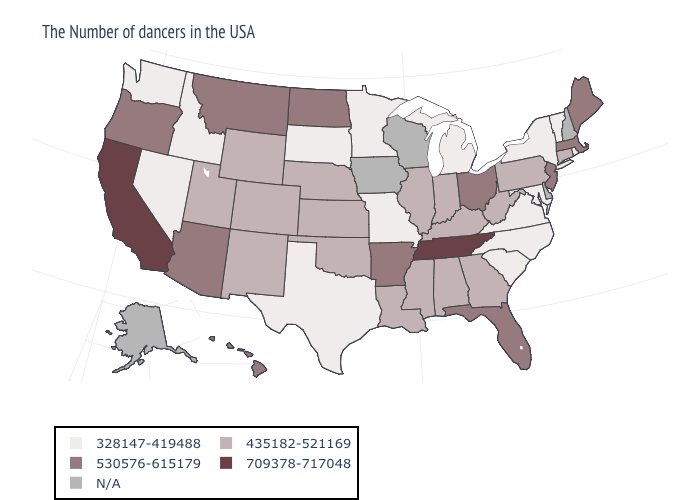Name the states that have a value in the range 328147-419488?
Answer briefly. Rhode Island, Vermont, New York, Maryland, Virginia, North Carolina, South Carolina, Michigan, Missouri, Minnesota, Texas, South Dakota, Idaho, Nevada, Washington. What is the value of Hawaii?
Answer briefly. 530576-615179. Does Michigan have the lowest value in the USA?
Concise answer only. Yes. What is the value of Maine?
Concise answer only. 530576-615179. What is the value of South Carolina?
Short answer required. 328147-419488. How many symbols are there in the legend?
Be succinct. 5. Name the states that have a value in the range 435182-521169?
Short answer required. Connecticut, Pennsylvania, West Virginia, Georgia, Kentucky, Indiana, Alabama, Illinois, Mississippi, Louisiana, Kansas, Nebraska, Oklahoma, Wyoming, Colorado, New Mexico, Utah. Does the first symbol in the legend represent the smallest category?
Write a very short answer. Yes. Among the states that border Alabama , does Florida have the lowest value?
Be succinct. No. What is the value of Louisiana?
Answer briefly. 435182-521169. Name the states that have a value in the range 435182-521169?
Write a very short answer. Connecticut, Pennsylvania, West Virginia, Georgia, Kentucky, Indiana, Alabama, Illinois, Mississippi, Louisiana, Kansas, Nebraska, Oklahoma, Wyoming, Colorado, New Mexico, Utah. Which states have the lowest value in the USA?
Give a very brief answer. Rhode Island, Vermont, New York, Maryland, Virginia, North Carolina, South Carolina, Michigan, Missouri, Minnesota, Texas, South Dakota, Idaho, Nevada, Washington. What is the highest value in states that border Oklahoma?
Answer briefly. 530576-615179. Name the states that have a value in the range 435182-521169?
Keep it brief. Connecticut, Pennsylvania, West Virginia, Georgia, Kentucky, Indiana, Alabama, Illinois, Mississippi, Louisiana, Kansas, Nebraska, Oklahoma, Wyoming, Colorado, New Mexico, Utah. What is the value of Missouri?
Write a very short answer. 328147-419488. 